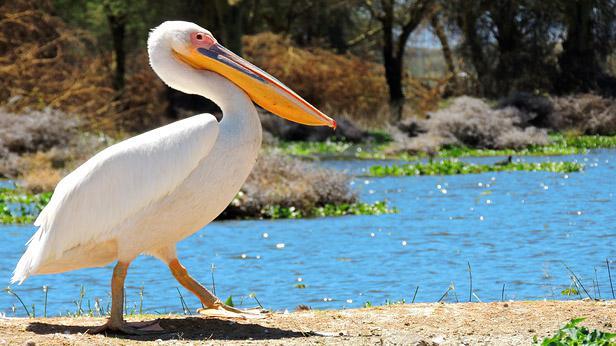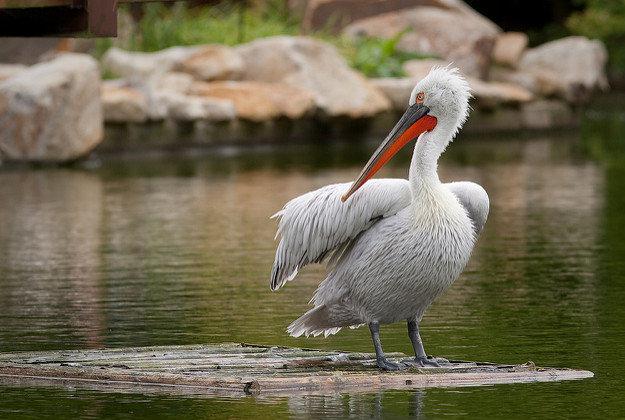The first image is the image on the left, the second image is the image on the right. For the images shown, is this caption "There  are at least 20 pelicans with white feathers and orange beak sitting together with no water in sight." true? Answer yes or no. No. The first image is the image on the left, the second image is the image on the right. For the images shown, is this caption "In at least one photo, there are fewer than 5 birds." true? Answer yes or no. Yes. 